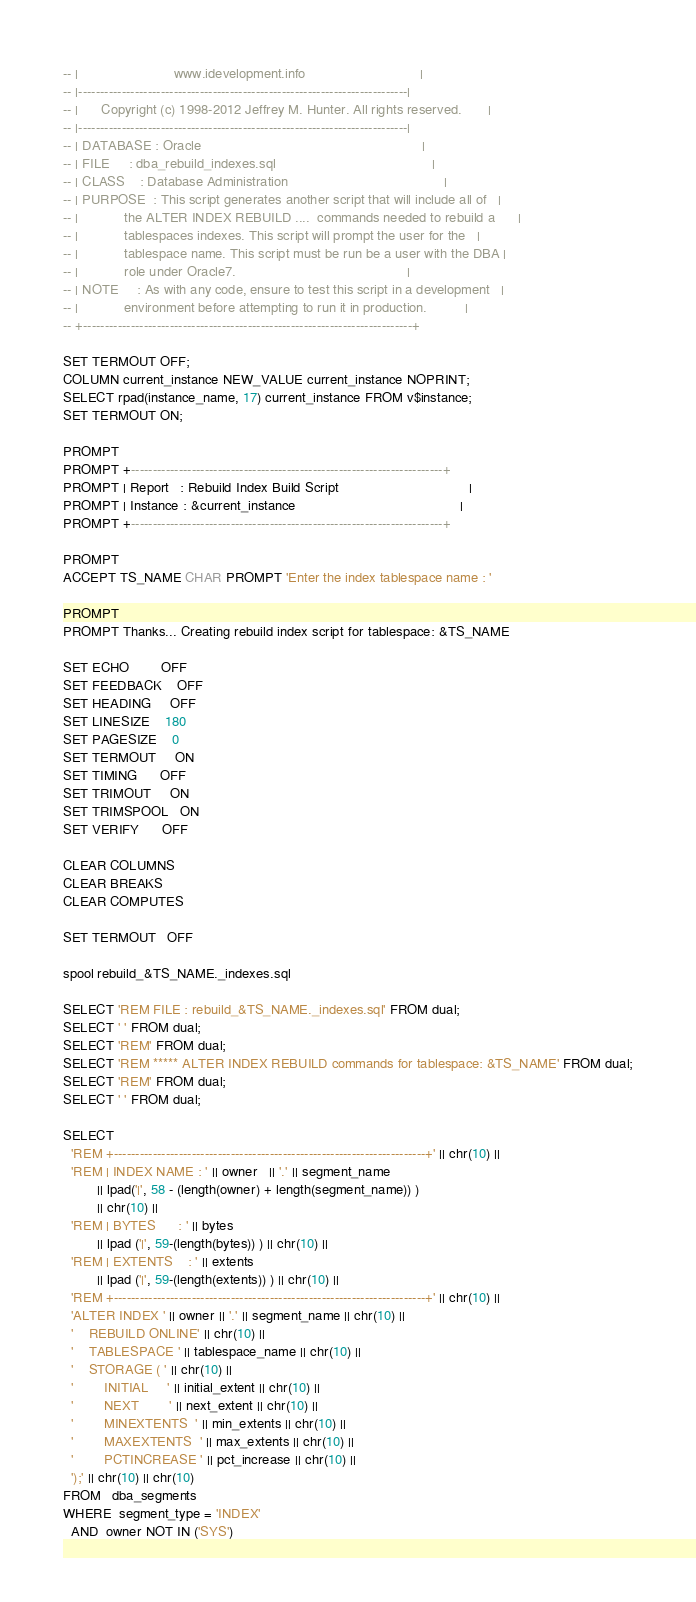<code> <loc_0><loc_0><loc_500><loc_500><_SQL_>-- |                         www.idevelopment.info                              |
-- |----------------------------------------------------------------------------|
-- |      Copyright (c) 1998-2012 Jeffrey M. Hunter. All rights reserved.       |
-- |----------------------------------------------------------------------------|
-- | DATABASE : Oracle                                                          |
-- | FILE     : dba_rebuild_indexes.sql                                         |
-- | CLASS    : Database Administration                                         |
-- | PURPOSE  : This script generates another script that will include all of   |
-- |            the ALTER INDEX REBUILD ....  commands needed to rebuild a      |
-- |            tablespaces indexes. This script will prompt the user for the   |
-- |            tablespace name. This script must be run be a user with the DBA |
-- |            role under Oracle7.                                             |
-- | NOTE     : As with any code, ensure to test this script in a development   |
-- |            environment before attempting to run it in production.          |
-- +----------------------------------------------------------------------------+

SET TERMOUT OFF;
COLUMN current_instance NEW_VALUE current_instance NOPRINT;
SELECT rpad(instance_name, 17) current_instance FROM v$instance;
SET TERMOUT ON;

PROMPT 
PROMPT +------------------------------------------------------------------------+
PROMPT | Report   : Rebuild Index Build Script                                  |
PROMPT | Instance : &current_instance                                           |
PROMPT +------------------------------------------------------------------------+

PROMPT 
ACCEPT TS_NAME CHAR PROMPT 'Enter the index tablespace name : '

PROMPT
PROMPT Thanks... Creating rebuild index script for tablespace: &TS_NAME

SET ECHO        OFF
SET FEEDBACK    OFF
SET HEADING     OFF
SET LINESIZE    180
SET PAGESIZE    0
SET TERMOUT     ON
SET TIMING      OFF
SET TRIMOUT     ON
SET TRIMSPOOL   ON
SET VERIFY      OFF

CLEAR COLUMNS
CLEAR BREAKS
CLEAR COMPUTES

SET TERMOUT   OFF

spool rebuild_&TS_NAME._indexes.sql

SELECT 'REM FILE : rebuild_&TS_NAME._indexes.sql' FROM dual;
SELECT ' ' FROM dual;
SELECT 'REM' FROM dual;
SELECT 'REM ***** ALTER INDEX REBUILD commands for tablespace: &TS_NAME' FROM dual;
SELECT 'REM' FROM dual;
SELECT ' ' FROM dual;

SELECT 
  'REM +------------------------------------------------------------------------+' || chr(10) ||
  'REM | INDEX NAME : ' || owner   || '.' || segment_name 
         || lpad('|', 58 - (length(owner) + length(segment_name)) )
         || chr(10) ||
  'REM | BYTES      : ' || bytes   
         || lpad ('|', 59-(length(bytes)) ) || chr(10) ||
  'REM | EXTENTS    : ' || extents 
         || lpad ('|', 59-(length(extents)) ) || chr(10) ||
  'REM +------------------------------------------------------------------------+' || chr(10) ||
  'ALTER INDEX ' || owner || '.' || segment_name || chr(10) ||
  '    REBUILD ONLINE' || chr(10) ||
  '    TABLESPACE ' || tablespace_name || chr(10) ||
  '    STORAGE ( ' || chr(10) ||
  '        INITIAL     ' || initial_extent || chr(10) ||
  '        NEXT        ' || next_extent || chr(10) ||
  '        MINEXTENTS  ' || min_extents || chr(10) ||
  '        MAXEXTENTS  ' || max_extents || chr(10) ||
  '        PCTINCREASE ' || pct_increase || chr(10) ||
  ');' || chr(10) || chr(10)
FROM   dba_segments
WHERE  segment_type = 'INDEX'
  AND  owner NOT IN ('SYS')</code> 